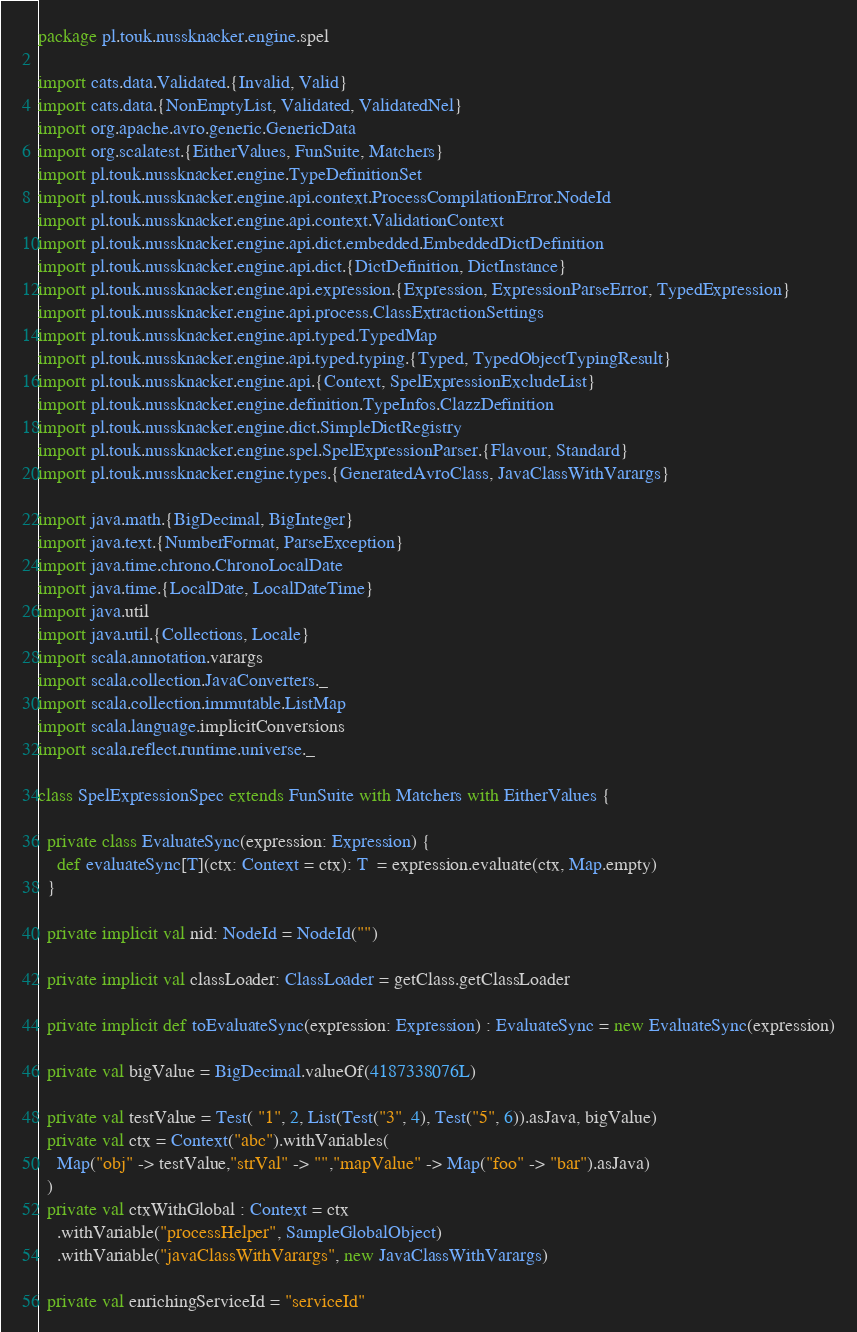<code> <loc_0><loc_0><loc_500><loc_500><_Scala_>package pl.touk.nussknacker.engine.spel

import cats.data.Validated.{Invalid, Valid}
import cats.data.{NonEmptyList, Validated, ValidatedNel}
import org.apache.avro.generic.GenericData
import org.scalatest.{EitherValues, FunSuite, Matchers}
import pl.touk.nussknacker.engine.TypeDefinitionSet
import pl.touk.nussknacker.engine.api.context.ProcessCompilationError.NodeId
import pl.touk.nussknacker.engine.api.context.ValidationContext
import pl.touk.nussknacker.engine.api.dict.embedded.EmbeddedDictDefinition
import pl.touk.nussknacker.engine.api.dict.{DictDefinition, DictInstance}
import pl.touk.nussknacker.engine.api.expression.{Expression, ExpressionParseError, TypedExpression}
import pl.touk.nussknacker.engine.api.process.ClassExtractionSettings
import pl.touk.nussknacker.engine.api.typed.TypedMap
import pl.touk.nussknacker.engine.api.typed.typing.{Typed, TypedObjectTypingResult}
import pl.touk.nussknacker.engine.api.{Context, SpelExpressionExcludeList}
import pl.touk.nussknacker.engine.definition.TypeInfos.ClazzDefinition
import pl.touk.nussknacker.engine.dict.SimpleDictRegistry
import pl.touk.nussknacker.engine.spel.SpelExpressionParser.{Flavour, Standard}
import pl.touk.nussknacker.engine.types.{GeneratedAvroClass, JavaClassWithVarargs}

import java.math.{BigDecimal, BigInteger}
import java.text.{NumberFormat, ParseException}
import java.time.chrono.ChronoLocalDate
import java.time.{LocalDate, LocalDateTime}
import java.util
import java.util.{Collections, Locale}
import scala.annotation.varargs
import scala.collection.JavaConverters._
import scala.collection.immutable.ListMap
import scala.language.implicitConversions
import scala.reflect.runtime.universe._

class SpelExpressionSpec extends FunSuite with Matchers with EitherValues {

  private class EvaluateSync(expression: Expression) {
    def evaluateSync[T](ctx: Context = ctx): T  = expression.evaluate(ctx, Map.empty)
  }

  private implicit val nid: NodeId = NodeId("")

  private implicit val classLoader: ClassLoader = getClass.getClassLoader

  private implicit def toEvaluateSync(expression: Expression) : EvaluateSync = new EvaluateSync(expression)

  private val bigValue = BigDecimal.valueOf(4187338076L)

  private val testValue = Test( "1", 2, List(Test("3", 4), Test("5", 6)).asJava, bigValue)
  private val ctx = Context("abc").withVariables(
    Map("obj" -> testValue,"strVal" -> "","mapValue" -> Map("foo" -> "bar").asJava)
  )
  private val ctxWithGlobal : Context = ctx
    .withVariable("processHelper", SampleGlobalObject)
    .withVariable("javaClassWithVarargs", new JavaClassWithVarargs)

  private val enrichingServiceId = "serviceId"
</code> 